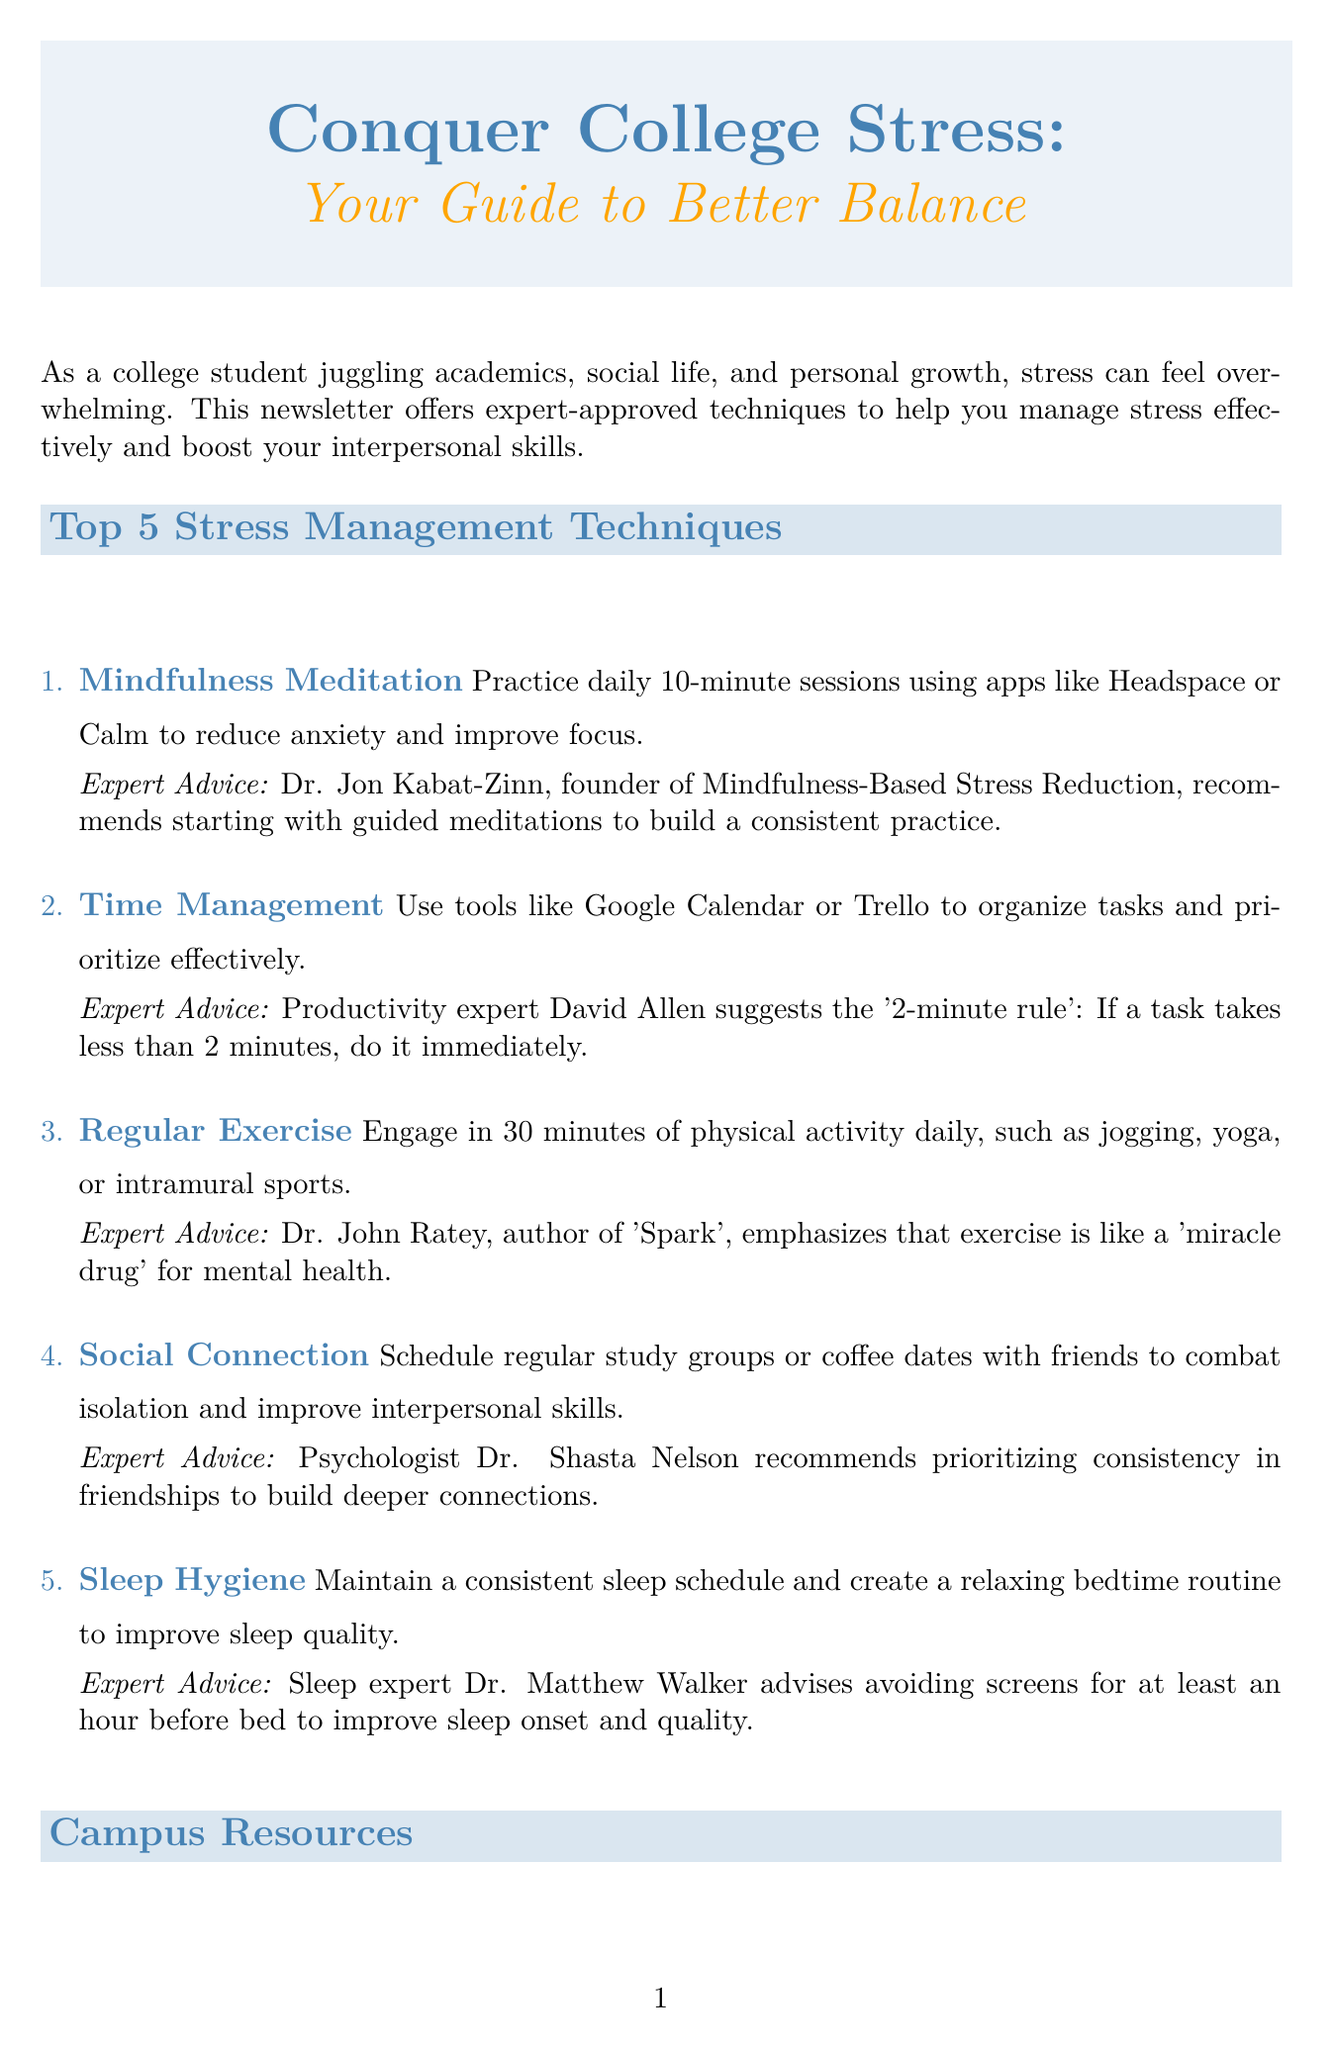What is the title of the newsletter? The title of the newsletter is provided at the beginning of the document as "Conquer College Stress: Your Guide to Better Balance."
Answer: Conquer College Stress: Your Guide to Better Balance Who is the author of the book recommended in the expert spotlight? The book recommendation is listed in the expert spotlight section, specifically mentioning "The Stress-Proof Brain" and its author.
Answer: Melanie Greenberg How many stress management techniques are listed? The list of stress management techniques is clearly outlined in the document.
Answer: 5 What rule does productivity expert David Allen suggest? The document mentions a specific strategy from David Allen related to time management that is described in the second technique.
Answer: 2-minute rule What is the main focus of Dr. Jon Kabat-Zinn's expert advice? The expert advice section provides insights from Dr. Jon Kabat-Zinn specifically related to mindfulness meditation.
Answer: Guided meditations What is the description of the University Counseling Center? The document provides a brief overview of available campus resources, including the University Counseling Center.
Answer: Offers free individual and group therapy sessions for students What type of quiz is included in the newsletter? The interactive element section introduces a specific type of quiz aimed at addressing student stress.
Answer: Quick Stress Assessment Quiz Which psychologist recommends prioritizing consistency in friendships? The counseling section showcases various expert opinions, one of which is from a psychologist discussing social connections.
Answer: Dr. Shasta Nelson 